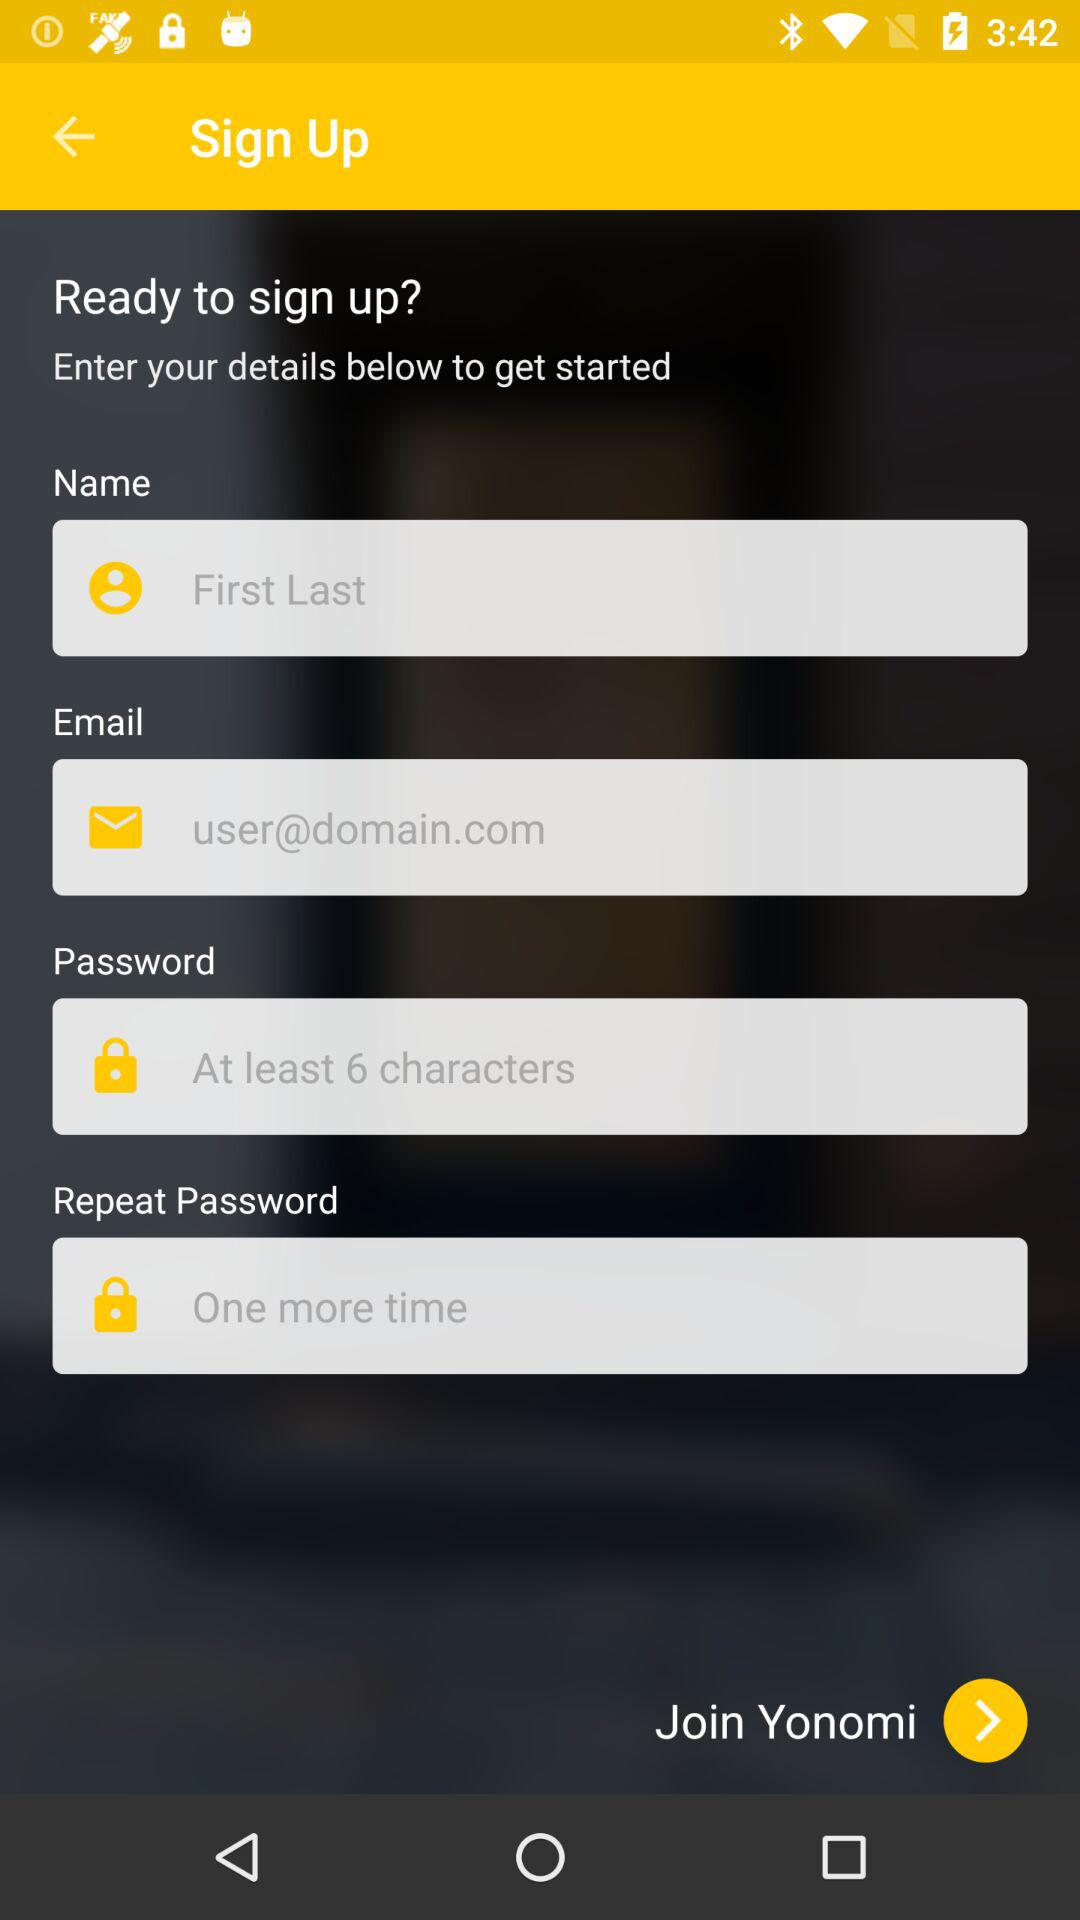What is the minimum number of characters required in a password? The minimum number of characters required in a password is 6. 